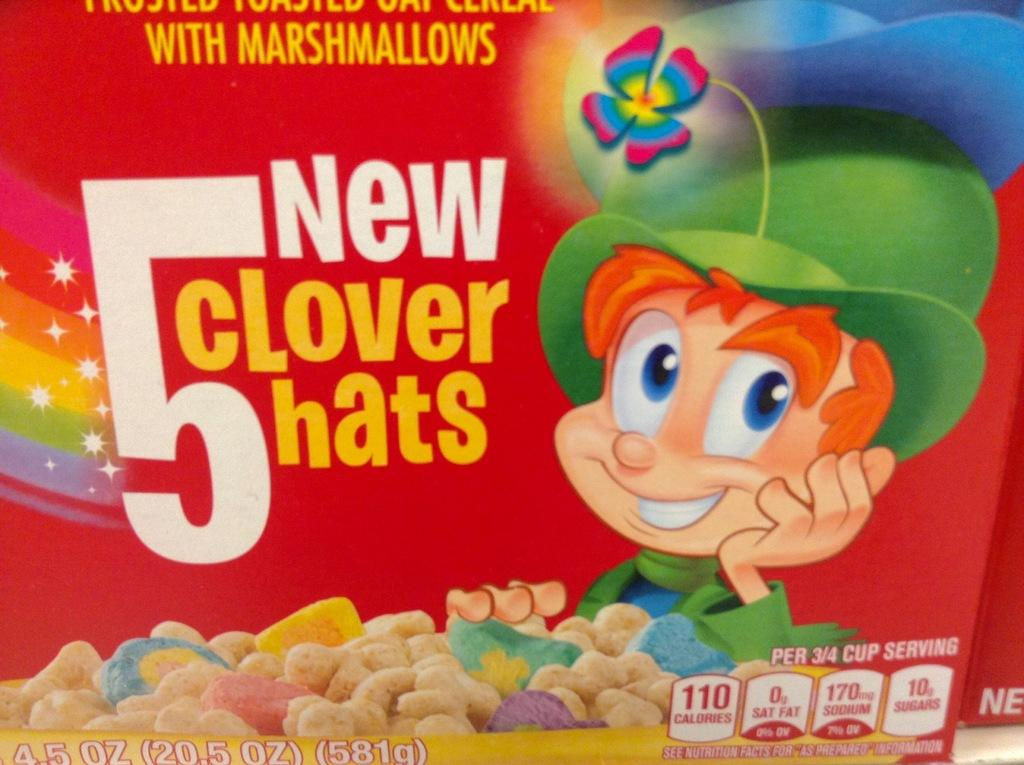What type of visual is the image? The image is a poster. What can be found on the poster besides the picture? There is text on the poster. What kind of image is featured on the poster? There is a picture of a cartoon on the poster. What else is depicted on the poster besides the cartoon? There are food items depicted on the poster. Can you see any blood on the cartoon character in the image? There is no blood present in the image; it features a cartoon character and food items on a poster. 